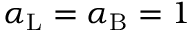Convert formula to latex. <formula><loc_0><loc_0><loc_500><loc_500>\alpha _ { L } = \alpha _ { B } = 1</formula> 